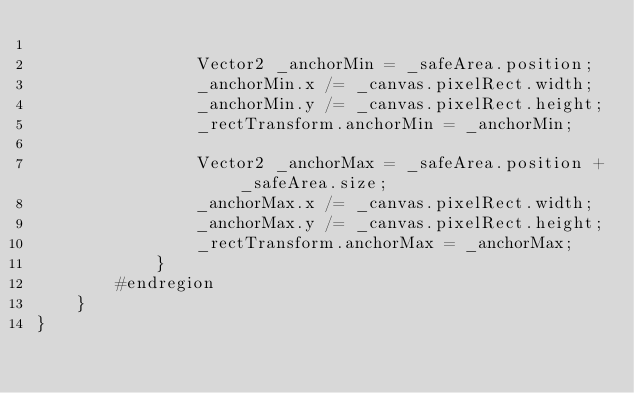<code> <loc_0><loc_0><loc_500><loc_500><_C#_>				
				Vector2 _anchorMin = _safeArea.position;
				_anchorMin.x /= _canvas.pixelRect.width;
				_anchorMin.y /= _canvas.pixelRect.height;
				_rectTransform.anchorMin = _anchorMin;
				
				Vector2 _anchorMax = _safeArea.position + _safeArea.size;
				_anchorMax.x /= _canvas.pixelRect.width;
				_anchorMax.y /= _canvas.pixelRect.height;
				_rectTransform.anchorMax = _anchorMax;
			}
		#endregion
	}
}</code> 